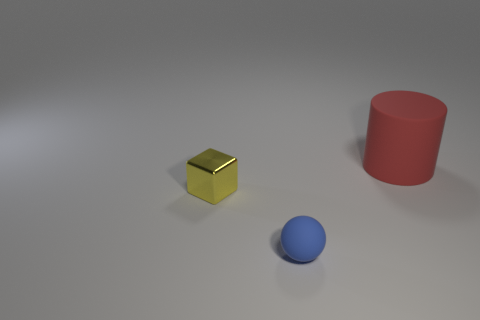How might the material of the objects affect the way they interact with light? The interaction of these objects with light would greatly depend on their materials. The cube appears reflective, suggesting a metallic or polished surface that would catch and reflect light, creating highlights and possibly reflecting its surroundings. The red cylinder and blue sphere seem to have matte surfaces, which would absorb light more evenly and produce more subdued, soft shadows. These differing material properties greatly contribute to the visual dynamics of the scene. 